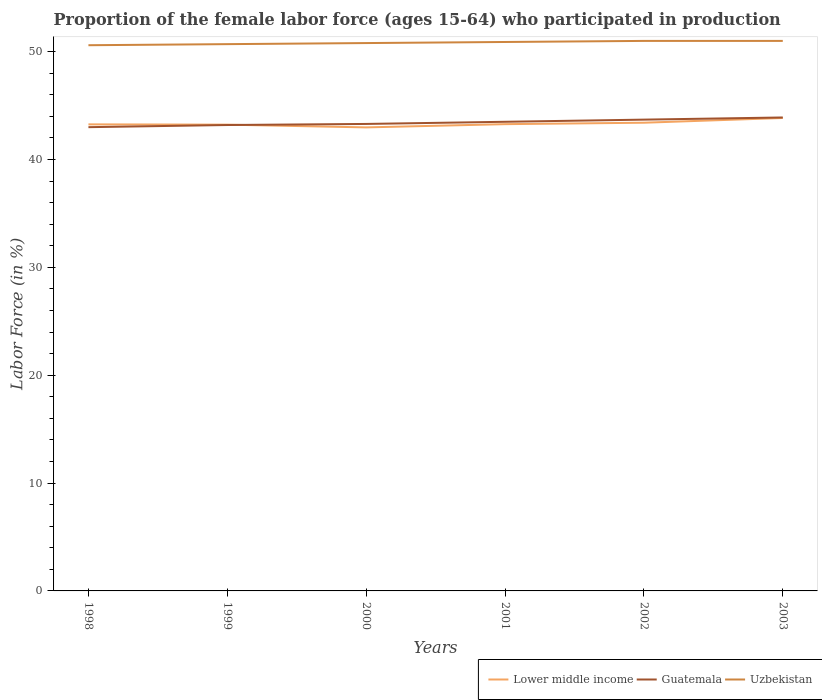How many different coloured lines are there?
Make the answer very short. 3. What is the total proportion of the female labor force who participated in production in Uzbekistan in the graph?
Give a very brief answer. -0.4. What is the difference between the highest and the second highest proportion of the female labor force who participated in production in Lower middle income?
Your answer should be compact. 0.87. What is the difference between the highest and the lowest proportion of the female labor force who participated in production in Lower middle income?
Your response must be concise. 2. Is the proportion of the female labor force who participated in production in Guatemala strictly greater than the proportion of the female labor force who participated in production in Uzbekistan over the years?
Provide a succinct answer. Yes. How many lines are there?
Give a very brief answer. 3. What is the difference between two consecutive major ticks on the Y-axis?
Offer a terse response. 10. How many legend labels are there?
Your response must be concise. 3. What is the title of the graph?
Offer a terse response. Proportion of the female labor force (ages 15-64) who participated in production. What is the label or title of the Y-axis?
Keep it short and to the point. Labor Force (in %). What is the Labor Force (in %) of Lower middle income in 1998?
Your answer should be very brief. 43.26. What is the Labor Force (in %) of Uzbekistan in 1998?
Your answer should be very brief. 50.6. What is the Labor Force (in %) in Lower middle income in 1999?
Your answer should be compact. 43.23. What is the Labor Force (in %) in Guatemala in 1999?
Your answer should be very brief. 43.2. What is the Labor Force (in %) in Uzbekistan in 1999?
Provide a short and direct response. 50.7. What is the Labor Force (in %) of Lower middle income in 2000?
Your response must be concise. 42.98. What is the Labor Force (in %) of Guatemala in 2000?
Your answer should be very brief. 43.3. What is the Labor Force (in %) in Uzbekistan in 2000?
Give a very brief answer. 50.8. What is the Labor Force (in %) in Lower middle income in 2001?
Offer a terse response. 43.28. What is the Labor Force (in %) in Guatemala in 2001?
Offer a terse response. 43.5. What is the Labor Force (in %) of Uzbekistan in 2001?
Ensure brevity in your answer.  50.9. What is the Labor Force (in %) of Lower middle income in 2002?
Make the answer very short. 43.41. What is the Labor Force (in %) in Guatemala in 2002?
Make the answer very short. 43.7. What is the Labor Force (in %) of Lower middle income in 2003?
Make the answer very short. 43.85. What is the Labor Force (in %) of Guatemala in 2003?
Provide a short and direct response. 43.9. Across all years, what is the maximum Labor Force (in %) of Lower middle income?
Ensure brevity in your answer.  43.85. Across all years, what is the maximum Labor Force (in %) of Guatemala?
Your answer should be compact. 43.9. Across all years, what is the minimum Labor Force (in %) of Lower middle income?
Provide a succinct answer. 42.98. Across all years, what is the minimum Labor Force (in %) of Guatemala?
Provide a short and direct response. 43. Across all years, what is the minimum Labor Force (in %) of Uzbekistan?
Offer a terse response. 50.6. What is the total Labor Force (in %) of Lower middle income in the graph?
Give a very brief answer. 260.02. What is the total Labor Force (in %) of Guatemala in the graph?
Make the answer very short. 260.6. What is the total Labor Force (in %) in Uzbekistan in the graph?
Keep it short and to the point. 305. What is the difference between the Labor Force (in %) in Lower middle income in 1998 and that in 1999?
Provide a short and direct response. 0.03. What is the difference between the Labor Force (in %) of Lower middle income in 1998 and that in 2000?
Offer a terse response. 0.28. What is the difference between the Labor Force (in %) in Guatemala in 1998 and that in 2000?
Provide a succinct answer. -0.3. What is the difference between the Labor Force (in %) in Uzbekistan in 1998 and that in 2000?
Ensure brevity in your answer.  -0.2. What is the difference between the Labor Force (in %) in Lower middle income in 1998 and that in 2001?
Your response must be concise. -0.02. What is the difference between the Labor Force (in %) of Guatemala in 1998 and that in 2001?
Offer a terse response. -0.5. What is the difference between the Labor Force (in %) of Uzbekistan in 1998 and that in 2001?
Your response must be concise. -0.3. What is the difference between the Labor Force (in %) of Lower middle income in 1998 and that in 2002?
Give a very brief answer. -0.15. What is the difference between the Labor Force (in %) of Lower middle income in 1998 and that in 2003?
Ensure brevity in your answer.  -0.59. What is the difference between the Labor Force (in %) of Lower middle income in 1999 and that in 2000?
Provide a short and direct response. 0.25. What is the difference between the Labor Force (in %) of Guatemala in 1999 and that in 2000?
Ensure brevity in your answer.  -0.1. What is the difference between the Labor Force (in %) in Uzbekistan in 1999 and that in 2000?
Offer a terse response. -0.1. What is the difference between the Labor Force (in %) of Lower middle income in 1999 and that in 2001?
Ensure brevity in your answer.  -0.05. What is the difference between the Labor Force (in %) in Lower middle income in 1999 and that in 2002?
Keep it short and to the point. -0.18. What is the difference between the Labor Force (in %) in Guatemala in 1999 and that in 2002?
Keep it short and to the point. -0.5. What is the difference between the Labor Force (in %) of Lower middle income in 1999 and that in 2003?
Your answer should be compact. -0.62. What is the difference between the Labor Force (in %) in Guatemala in 1999 and that in 2003?
Keep it short and to the point. -0.7. What is the difference between the Labor Force (in %) in Uzbekistan in 1999 and that in 2003?
Give a very brief answer. -0.3. What is the difference between the Labor Force (in %) in Lower middle income in 2000 and that in 2001?
Ensure brevity in your answer.  -0.3. What is the difference between the Labor Force (in %) of Lower middle income in 2000 and that in 2002?
Your answer should be compact. -0.43. What is the difference between the Labor Force (in %) in Uzbekistan in 2000 and that in 2002?
Provide a succinct answer. -0.2. What is the difference between the Labor Force (in %) of Lower middle income in 2000 and that in 2003?
Make the answer very short. -0.87. What is the difference between the Labor Force (in %) of Guatemala in 2000 and that in 2003?
Your response must be concise. -0.6. What is the difference between the Labor Force (in %) of Lower middle income in 2001 and that in 2002?
Make the answer very short. -0.13. What is the difference between the Labor Force (in %) of Guatemala in 2001 and that in 2002?
Ensure brevity in your answer.  -0.2. What is the difference between the Labor Force (in %) in Lower middle income in 2001 and that in 2003?
Your answer should be very brief. -0.57. What is the difference between the Labor Force (in %) in Guatemala in 2001 and that in 2003?
Your response must be concise. -0.4. What is the difference between the Labor Force (in %) in Uzbekistan in 2001 and that in 2003?
Your answer should be very brief. -0.1. What is the difference between the Labor Force (in %) of Lower middle income in 2002 and that in 2003?
Provide a succinct answer. -0.44. What is the difference between the Labor Force (in %) in Guatemala in 2002 and that in 2003?
Make the answer very short. -0.2. What is the difference between the Labor Force (in %) of Lower middle income in 1998 and the Labor Force (in %) of Guatemala in 1999?
Your answer should be very brief. 0.06. What is the difference between the Labor Force (in %) of Lower middle income in 1998 and the Labor Force (in %) of Uzbekistan in 1999?
Your answer should be compact. -7.44. What is the difference between the Labor Force (in %) of Guatemala in 1998 and the Labor Force (in %) of Uzbekistan in 1999?
Your answer should be compact. -7.7. What is the difference between the Labor Force (in %) in Lower middle income in 1998 and the Labor Force (in %) in Guatemala in 2000?
Your answer should be very brief. -0.04. What is the difference between the Labor Force (in %) of Lower middle income in 1998 and the Labor Force (in %) of Uzbekistan in 2000?
Your response must be concise. -7.54. What is the difference between the Labor Force (in %) in Guatemala in 1998 and the Labor Force (in %) in Uzbekistan in 2000?
Your response must be concise. -7.8. What is the difference between the Labor Force (in %) of Lower middle income in 1998 and the Labor Force (in %) of Guatemala in 2001?
Offer a very short reply. -0.24. What is the difference between the Labor Force (in %) in Lower middle income in 1998 and the Labor Force (in %) in Uzbekistan in 2001?
Your response must be concise. -7.64. What is the difference between the Labor Force (in %) of Lower middle income in 1998 and the Labor Force (in %) of Guatemala in 2002?
Your answer should be very brief. -0.44. What is the difference between the Labor Force (in %) of Lower middle income in 1998 and the Labor Force (in %) of Uzbekistan in 2002?
Provide a short and direct response. -7.74. What is the difference between the Labor Force (in %) in Guatemala in 1998 and the Labor Force (in %) in Uzbekistan in 2002?
Give a very brief answer. -8. What is the difference between the Labor Force (in %) in Lower middle income in 1998 and the Labor Force (in %) in Guatemala in 2003?
Your response must be concise. -0.64. What is the difference between the Labor Force (in %) of Lower middle income in 1998 and the Labor Force (in %) of Uzbekistan in 2003?
Keep it short and to the point. -7.74. What is the difference between the Labor Force (in %) of Guatemala in 1998 and the Labor Force (in %) of Uzbekistan in 2003?
Ensure brevity in your answer.  -8. What is the difference between the Labor Force (in %) of Lower middle income in 1999 and the Labor Force (in %) of Guatemala in 2000?
Your answer should be very brief. -0.07. What is the difference between the Labor Force (in %) of Lower middle income in 1999 and the Labor Force (in %) of Uzbekistan in 2000?
Your answer should be compact. -7.57. What is the difference between the Labor Force (in %) of Lower middle income in 1999 and the Labor Force (in %) of Guatemala in 2001?
Ensure brevity in your answer.  -0.27. What is the difference between the Labor Force (in %) of Lower middle income in 1999 and the Labor Force (in %) of Uzbekistan in 2001?
Provide a short and direct response. -7.67. What is the difference between the Labor Force (in %) of Lower middle income in 1999 and the Labor Force (in %) of Guatemala in 2002?
Provide a short and direct response. -0.47. What is the difference between the Labor Force (in %) in Lower middle income in 1999 and the Labor Force (in %) in Uzbekistan in 2002?
Keep it short and to the point. -7.77. What is the difference between the Labor Force (in %) in Guatemala in 1999 and the Labor Force (in %) in Uzbekistan in 2002?
Provide a short and direct response. -7.8. What is the difference between the Labor Force (in %) in Lower middle income in 1999 and the Labor Force (in %) in Guatemala in 2003?
Give a very brief answer. -0.67. What is the difference between the Labor Force (in %) of Lower middle income in 1999 and the Labor Force (in %) of Uzbekistan in 2003?
Offer a very short reply. -7.77. What is the difference between the Labor Force (in %) of Guatemala in 1999 and the Labor Force (in %) of Uzbekistan in 2003?
Your answer should be very brief. -7.8. What is the difference between the Labor Force (in %) of Lower middle income in 2000 and the Labor Force (in %) of Guatemala in 2001?
Keep it short and to the point. -0.52. What is the difference between the Labor Force (in %) in Lower middle income in 2000 and the Labor Force (in %) in Uzbekistan in 2001?
Keep it short and to the point. -7.92. What is the difference between the Labor Force (in %) in Lower middle income in 2000 and the Labor Force (in %) in Guatemala in 2002?
Make the answer very short. -0.72. What is the difference between the Labor Force (in %) in Lower middle income in 2000 and the Labor Force (in %) in Uzbekistan in 2002?
Keep it short and to the point. -8.02. What is the difference between the Labor Force (in %) in Guatemala in 2000 and the Labor Force (in %) in Uzbekistan in 2002?
Your answer should be compact. -7.7. What is the difference between the Labor Force (in %) of Lower middle income in 2000 and the Labor Force (in %) of Guatemala in 2003?
Make the answer very short. -0.92. What is the difference between the Labor Force (in %) in Lower middle income in 2000 and the Labor Force (in %) in Uzbekistan in 2003?
Give a very brief answer. -8.02. What is the difference between the Labor Force (in %) in Guatemala in 2000 and the Labor Force (in %) in Uzbekistan in 2003?
Your answer should be compact. -7.7. What is the difference between the Labor Force (in %) in Lower middle income in 2001 and the Labor Force (in %) in Guatemala in 2002?
Your answer should be compact. -0.42. What is the difference between the Labor Force (in %) in Lower middle income in 2001 and the Labor Force (in %) in Uzbekistan in 2002?
Offer a very short reply. -7.72. What is the difference between the Labor Force (in %) in Lower middle income in 2001 and the Labor Force (in %) in Guatemala in 2003?
Keep it short and to the point. -0.62. What is the difference between the Labor Force (in %) in Lower middle income in 2001 and the Labor Force (in %) in Uzbekistan in 2003?
Your response must be concise. -7.72. What is the difference between the Labor Force (in %) in Guatemala in 2001 and the Labor Force (in %) in Uzbekistan in 2003?
Keep it short and to the point. -7.5. What is the difference between the Labor Force (in %) in Lower middle income in 2002 and the Labor Force (in %) in Guatemala in 2003?
Provide a short and direct response. -0.49. What is the difference between the Labor Force (in %) of Lower middle income in 2002 and the Labor Force (in %) of Uzbekistan in 2003?
Ensure brevity in your answer.  -7.59. What is the difference between the Labor Force (in %) of Guatemala in 2002 and the Labor Force (in %) of Uzbekistan in 2003?
Make the answer very short. -7.3. What is the average Labor Force (in %) of Lower middle income per year?
Keep it short and to the point. 43.34. What is the average Labor Force (in %) in Guatemala per year?
Your answer should be very brief. 43.43. What is the average Labor Force (in %) in Uzbekistan per year?
Offer a very short reply. 50.83. In the year 1998, what is the difference between the Labor Force (in %) of Lower middle income and Labor Force (in %) of Guatemala?
Keep it short and to the point. 0.26. In the year 1998, what is the difference between the Labor Force (in %) of Lower middle income and Labor Force (in %) of Uzbekistan?
Ensure brevity in your answer.  -7.34. In the year 1998, what is the difference between the Labor Force (in %) of Guatemala and Labor Force (in %) of Uzbekistan?
Your answer should be compact. -7.6. In the year 1999, what is the difference between the Labor Force (in %) in Lower middle income and Labor Force (in %) in Guatemala?
Give a very brief answer. 0.03. In the year 1999, what is the difference between the Labor Force (in %) of Lower middle income and Labor Force (in %) of Uzbekistan?
Offer a very short reply. -7.47. In the year 2000, what is the difference between the Labor Force (in %) of Lower middle income and Labor Force (in %) of Guatemala?
Ensure brevity in your answer.  -0.32. In the year 2000, what is the difference between the Labor Force (in %) of Lower middle income and Labor Force (in %) of Uzbekistan?
Provide a succinct answer. -7.82. In the year 2000, what is the difference between the Labor Force (in %) of Guatemala and Labor Force (in %) of Uzbekistan?
Ensure brevity in your answer.  -7.5. In the year 2001, what is the difference between the Labor Force (in %) in Lower middle income and Labor Force (in %) in Guatemala?
Make the answer very short. -0.22. In the year 2001, what is the difference between the Labor Force (in %) in Lower middle income and Labor Force (in %) in Uzbekistan?
Offer a terse response. -7.62. In the year 2002, what is the difference between the Labor Force (in %) of Lower middle income and Labor Force (in %) of Guatemala?
Offer a very short reply. -0.29. In the year 2002, what is the difference between the Labor Force (in %) in Lower middle income and Labor Force (in %) in Uzbekistan?
Give a very brief answer. -7.59. In the year 2003, what is the difference between the Labor Force (in %) of Lower middle income and Labor Force (in %) of Guatemala?
Offer a very short reply. -0.05. In the year 2003, what is the difference between the Labor Force (in %) of Lower middle income and Labor Force (in %) of Uzbekistan?
Ensure brevity in your answer.  -7.15. What is the ratio of the Labor Force (in %) in Uzbekistan in 1998 to that in 2000?
Make the answer very short. 1. What is the ratio of the Labor Force (in %) in Lower middle income in 1998 to that in 2002?
Make the answer very short. 1. What is the ratio of the Labor Force (in %) in Lower middle income in 1998 to that in 2003?
Keep it short and to the point. 0.99. What is the ratio of the Labor Force (in %) of Guatemala in 1998 to that in 2003?
Your answer should be very brief. 0.98. What is the ratio of the Labor Force (in %) in Lower middle income in 1999 to that in 2000?
Offer a terse response. 1.01. What is the ratio of the Labor Force (in %) of Guatemala in 1999 to that in 2000?
Provide a short and direct response. 1. What is the ratio of the Labor Force (in %) of Uzbekistan in 1999 to that in 2000?
Your response must be concise. 1. What is the ratio of the Labor Force (in %) of Lower middle income in 1999 to that in 2001?
Keep it short and to the point. 1. What is the ratio of the Labor Force (in %) of Guatemala in 1999 to that in 2002?
Ensure brevity in your answer.  0.99. What is the ratio of the Labor Force (in %) of Lower middle income in 1999 to that in 2003?
Your response must be concise. 0.99. What is the ratio of the Labor Force (in %) in Guatemala in 1999 to that in 2003?
Your response must be concise. 0.98. What is the ratio of the Labor Force (in %) of Uzbekistan in 1999 to that in 2003?
Your answer should be very brief. 0.99. What is the ratio of the Labor Force (in %) of Uzbekistan in 2000 to that in 2001?
Your answer should be compact. 1. What is the ratio of the Labor Force (in %) of Lower middle income in 2000 to that in 2002?
Your answer should be compact. 0.99. What is the ratio of the Labor Force (in %) in Uzbekistan in 2000 to that in 2002?
Provide a short and direct response. 1. What is the ratio of the Labor Force (in %) of Lower middle income in 2000 to that in 2003?
Provide a short and direct response. 0.98. What is the ratio of the Labor Force (in %) of Guatemala in 2000 to that in 2003?
Offer a very short reply. 0.99. What is the ratio of the Labor Force (in %) of Uzbekistan in 2000 to that in 2003?
Keep it short and to the point. 1. What is the ratio of the Labor Force (in %) in Guatemala in 2001 to that in 2002?
Keep it short and to the point. 1. What is the ratio of the Labor Force (in %) of Uzbekistan in 2001 to that in 2002?
Your response must be concise. 1. What is the ratio of the Labor Force (in %) in Guatemala in 2001 to that in 2003?
Give a very brief answer. 0.99. What is the ratio of the Labor Force (in %) of Uzbekistan in 2001 to that in 2003?
Provide a short and direct response. 1. What is the ratio of the Labor Force (in %) of Guatemala in 2002 to that in 2003?
Offer a terse response. 1. What is the ratio of the Labor Force (in %) in Uzbekistan in 2002 to that in 2003?
Ensure brevity in your answer.  1. What is the difference between the highest and the second highest Labor Force (in %) in Lower middle income?
Keep it short and to the point. 0.44. What is the difference between the highest and the second highest Labor Force (in %) of Guatemala?
Your response must be concise. 0.2. What is the difference between the highest and the lowest Labor Force (in %) of Lower middle income?
Give a very brief answer. 0.87. What is the difference between the highest and the lowest Labor Force (in %) in Guatemala?
Provide a short and direct response. 0.9. 